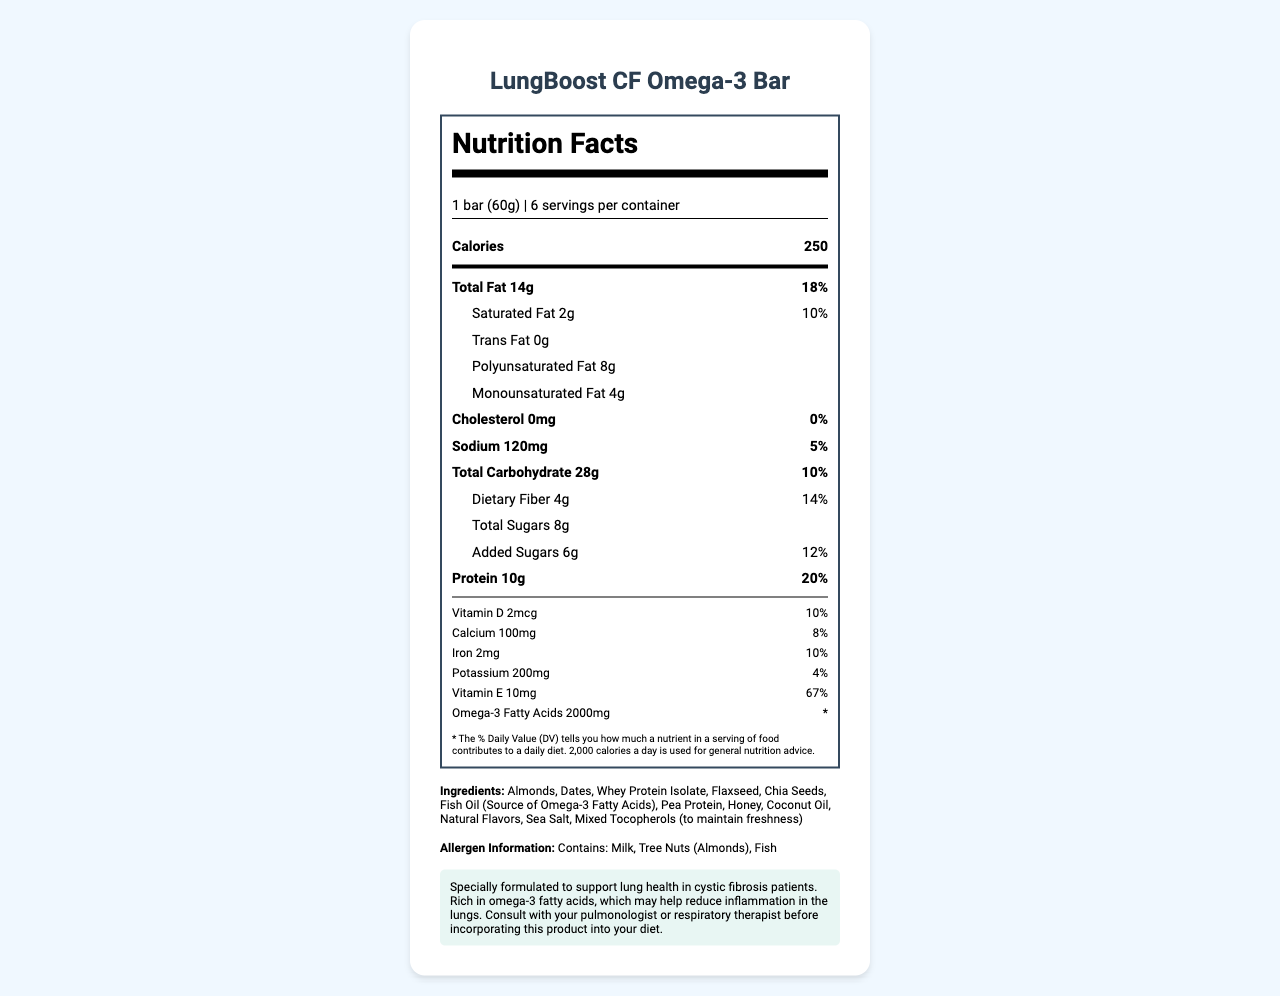what is the serving size of the LungBoost CF Omega-3 Bar? The serving size is listed at the beginning of the nutrition facts label.
Answer: 1 bar (60g) How many servings are in each container? The servings per container are explicitly stated near the top of the nutrition label, right after the serving size.
Answer: 6 How many calories does one serving of the LungBoost CF Omega-3 Bar provide? The number of calories per serving is listed prominently on the nutrition facts label.
Answer: 250 What percentage of the daily value of total fat does one bar provide? The daily value percentage for total fat is listed next to the total fat amount on the nutrition label.
Answer: 18% What are the main ingredients of the LungBoost CF Omega-3 Bar? The main ingredients are listed towards the end of the document under the ingredients section.
Answer: Almonds, Dates, Whey Protein Isolate, Flaxseed, Chia Seeds, Fish Oil, Pea Protein, Honey, Coconut Oil, Natural Flavors, Sea Salt, Mixed Tocopherols Which vitamin is found in the highest percentage of the daily value in the LungBoost CF Omega-3 Bar? A. Vitamin D B. Calcium C. Iron D. Vitamin E The nutrition facts show Vitamin E at 67%, which is the highest percentage among listed vitamins and minerals.
Answer: D How much protein is in one serving of the LungBoost CF Omega-3 Bar? A. 5g B. 10g C. 15g D. 20g One serving contains 10 grams of protein, as listed clearly on the label.
Answer: B Is this product a good source of dietary fiber? It provides 14% of the daily value for dietary fiber per serving, which is a notable amount.
Answer: Yes Does the LungBoost CF Omega-3 Bar contain any trans fat? The nutrition facts label indicates that the LungBoost CF Omega-3 Bar has 0 grams of trans fat.
Answer: No Does the LungBoost CF Omega-3 Bar contain any allergens? The allergens listed are milk, tree nuts (almonds), and fish.
Answer: Yes Summarize the main purpose and nutritional highlights of the LungBoost CF Omega-3 Bar. The document outlines the product's nutrition facts, ingredients, and its intended health benefits for cystic fibrosis patients.
Answer: The LungBoost CF Omega-3 Bar is formulated to support lung health in cystic fibrosis patients. It is rich in omega-3 fatty acids, provides 250 calories per bar, 10 grams of protein, significant amounts of Vitamin E, and a good source of dietary fiber. It contains a variety of healthy ingredients like almonds, dates, and flaxseed, but also includes common allergens such as milk, tree nuts, and fish. How much Omega-3 Fatty Acids does each bar contain? The amount of omega-3 fatty acids is listed under the nutrition facts as 2000mg.
Answer: 2000mg What is the % Daily Value for Vitamin D in the LungBoost CF Omega-3 Bar? The label shows that each bar provides 10% of the daily value for Vitamin D.
Answer: 10% Does the LungBoost CF Omega-3 Bar contain any cholesterol? The nutrition label indicates 0mg of cholesterol, which is 0% of the daily value.
Answer: No Can we determine the price of the LungBoost CF Omega-3 Bar from the document? The document does not provide any information about the price of the product.
Answer: Not enough information 